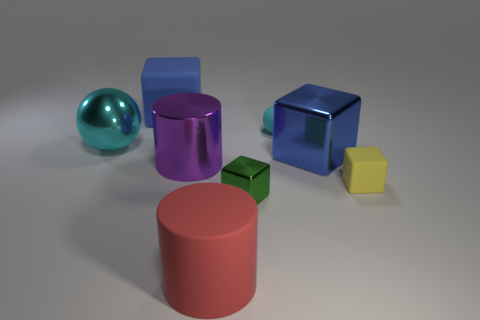If these objects were to be used in a learning environment for children, what could they teach? These objects could be excellent tools for teaching children a variety of concepts. For example, the different shapes can be used to teach geometry, with the spherical, cubic, and cylindrical forms introducing solids. The variety in color can help with color recognition and vocabulary building. Furthermore, by physically interacting with the objects, children could improve their motor skills and learn about spatial relationships and size comparison. 